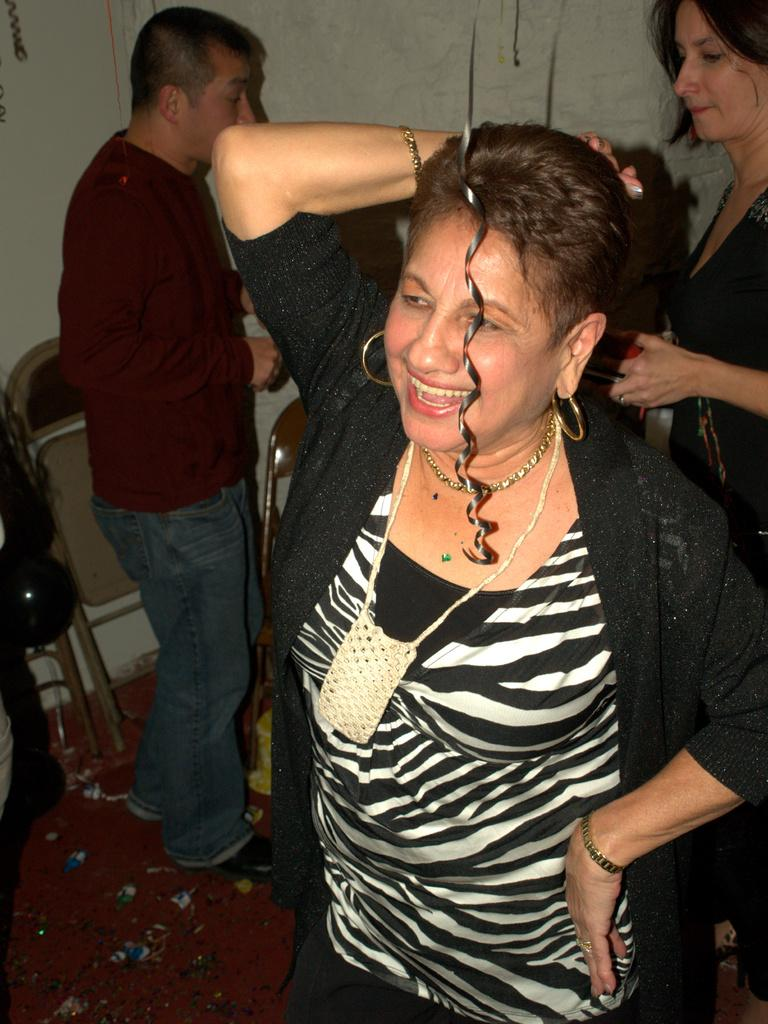What are the people in the image doing? The people are standing in the image. On what surface are the people standing? The people are standing on the floor. What can be seen in the background of the image? Walls, chairs, confetti, balloons, and a carpet are visible in the background of the image. What type of bone can be seen in the image? There is no bone present in the image. Can you tell me how many ducks are visible in the image? There are no ducks present in the image. 